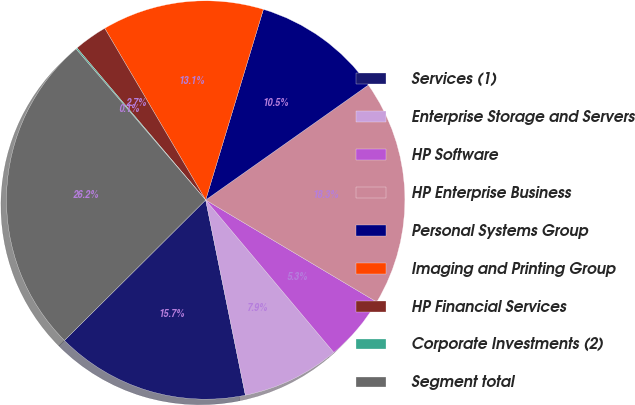<chart> <loc_0><loc_0><loc_500><loc_500><pie_chart><fcel>Services (1)<fcel>Enterprise Storage and Servers<fcel>HP Software<fcel>HP Enterprise Business<fcel>Personal Systems Group<fcel>Imaging and Printing Group<fcel>HP Financial Services<fcel>Corporate Investments (2)<fcel>Segment total<nl><fcel>15.74%<fcel>7.93%<fcel>5.32%<fcel>18.35%<fcel>10.53%<fcel>13.14%<fcel>2.72%<fcel>0.11%<fcel>26.17%<nl></chart> 